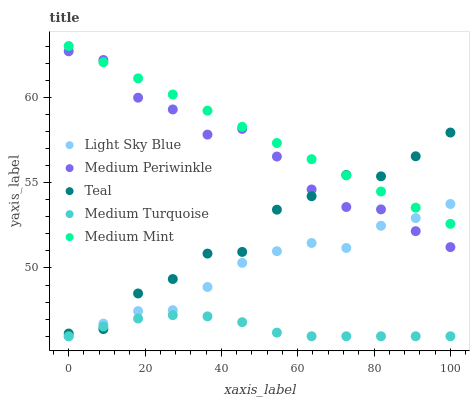Does Medium Turquoise have the minimum area under the curve?
Answer yes or no. Yes. Does Medium Mint have the maximum area under the curve?
Answer yes or no. Yes. Does Light Sky Blue have the minimum area under the curve?
Answer yes or no. No. Does Light Sky Blue have the maximum area under the curve?
Answer yes or no. No. Is Medium Mint the smoothest?
Answer yes or no. Yes. Is Teal the roughest?
Answer yes or no. Yes. Is Light Sky Blue the smoothest?
Answer yes or no. No. Is Light Sky Blue the roughest?
Answer yes or no. No. Does Light Sky Blue have the lowest value?
Answer yes or no. Yes. Does Medium Periwinkle have the lowest value?
Answer yes or no. No. Does Medium Mint have the highest value?
Answer yes or no. Yes. Does Light Sky Blue have the highest value?
Answer yes or no. No. Is Medium Turquoise less than Medium Mint?
Answer yes or no. Yes. Is Medium Periwinkle greater than Medium Turquoise?
Answer yes or no. Yes. Does Teal intersect Medium Periwinkle?
Answer yes or no. Yes. Is Teal less than Medium Periwinkle?
Answer yes or no. No. Is Teal greater than Medium Periwinkle?
Answer yes or no. No. Does Medium Turquoise intersect Medium Mint?
Answer yes or no. No. 